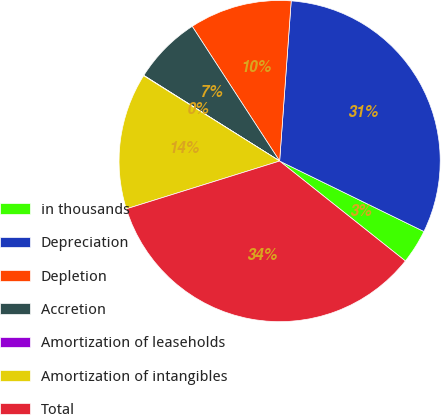<chart> <loc_0><loc_0><loc_500><loc_500><pie_chart><fcel>in thousands<fcel>Depreciation<fcel>Depletion<fcel>Accretion<fcel>Amortization of leaseholds<fcel>Amortization of intangibles<fcel>Total<nl><fcel>3.46%<fcel>31.08%<fcel>10.31%<fcel>6.88%<fcel>0.04%<fcel>13.73%<fcel>34.5%<nl></chart> 